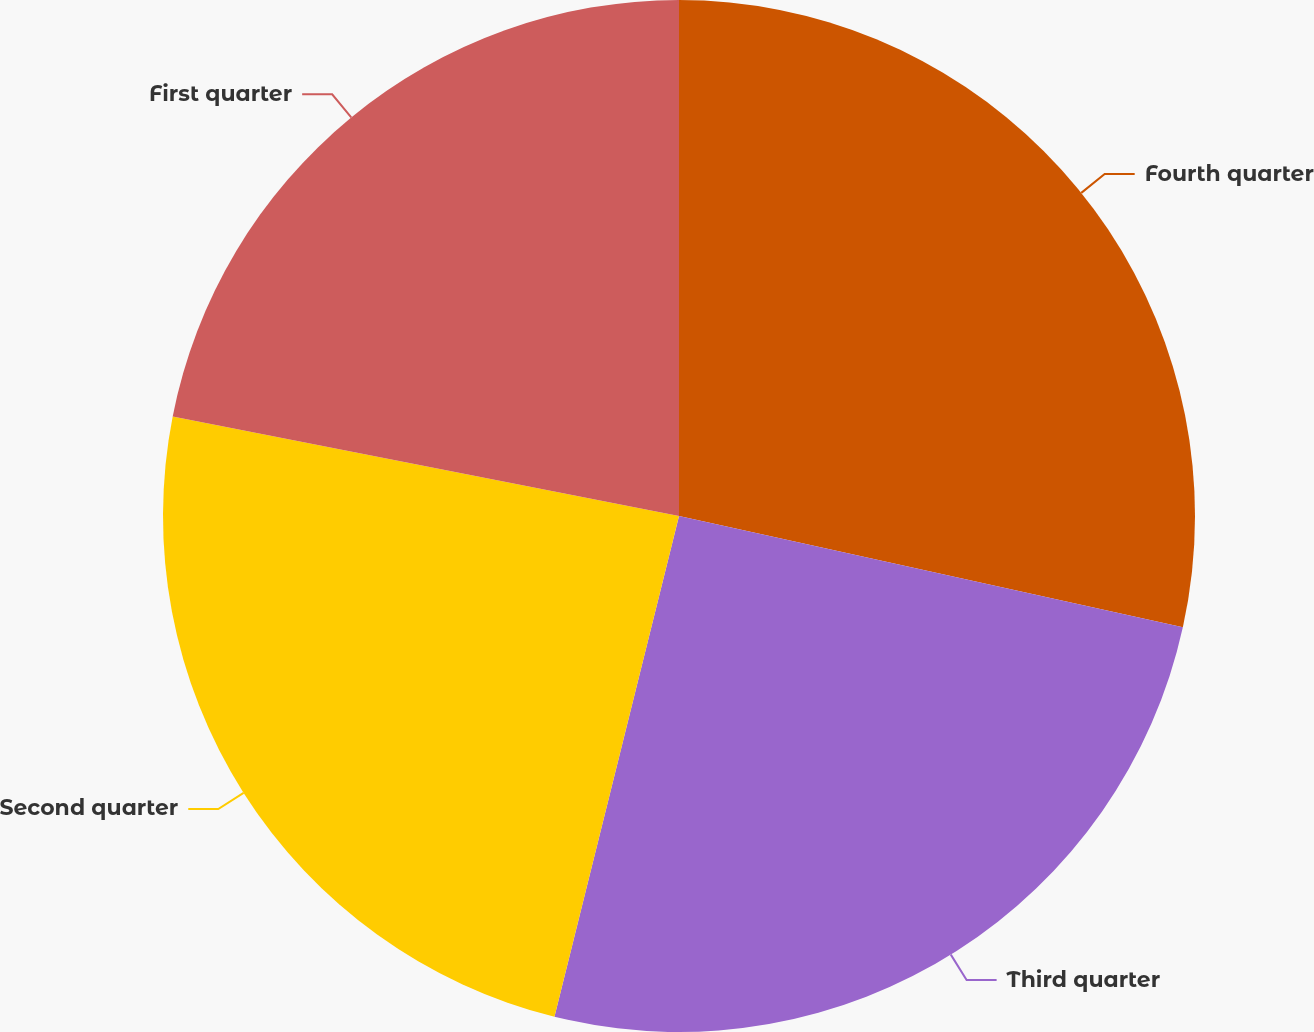<chart> <loc_0><loc_0><loc_500><loc_500><pie_chart><fcel>Fourth quarter<fcel>Third quarter<fcel>Second quarter<fcel>First quarter<nl><fcel>28.46%<fcel>25.42%<fcel>24.21%<fcel>21.91%<nl></chart> 